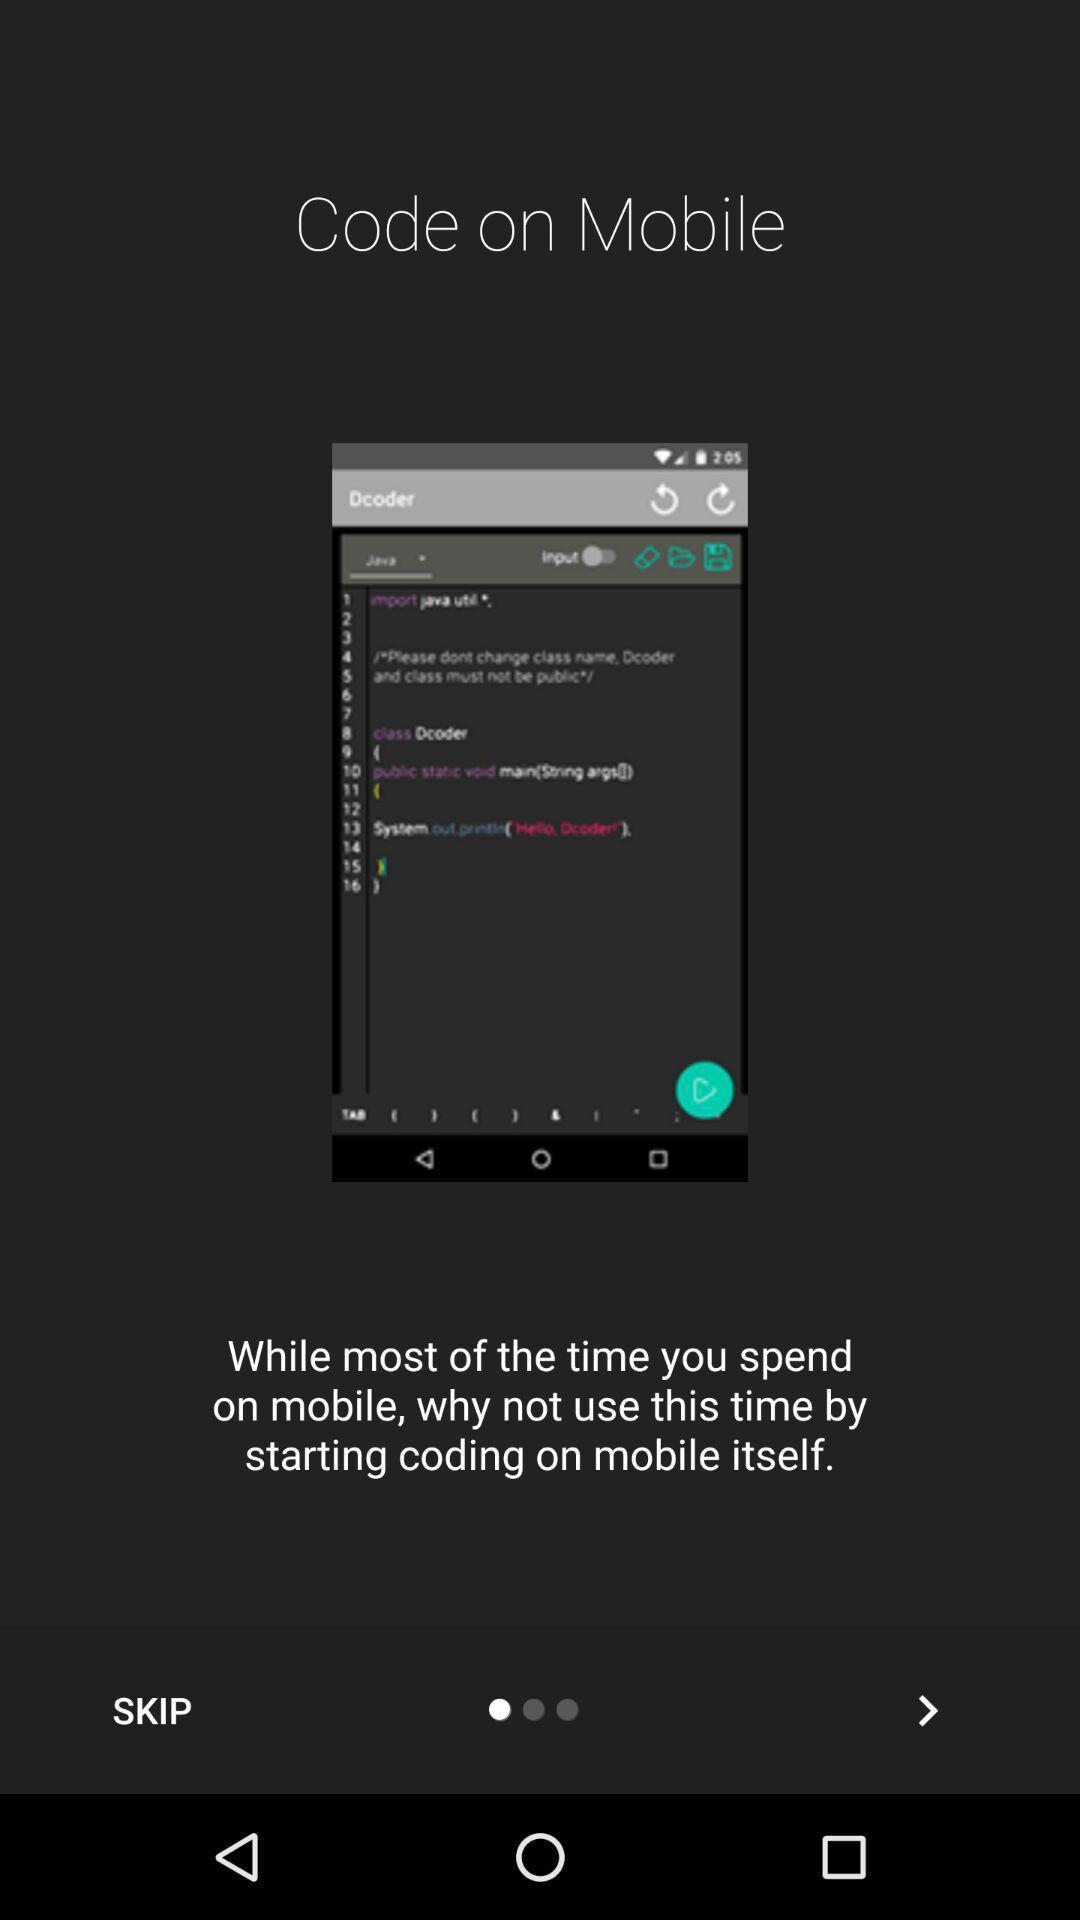Provide a textual representation of this image. Welcome page for a new application. 